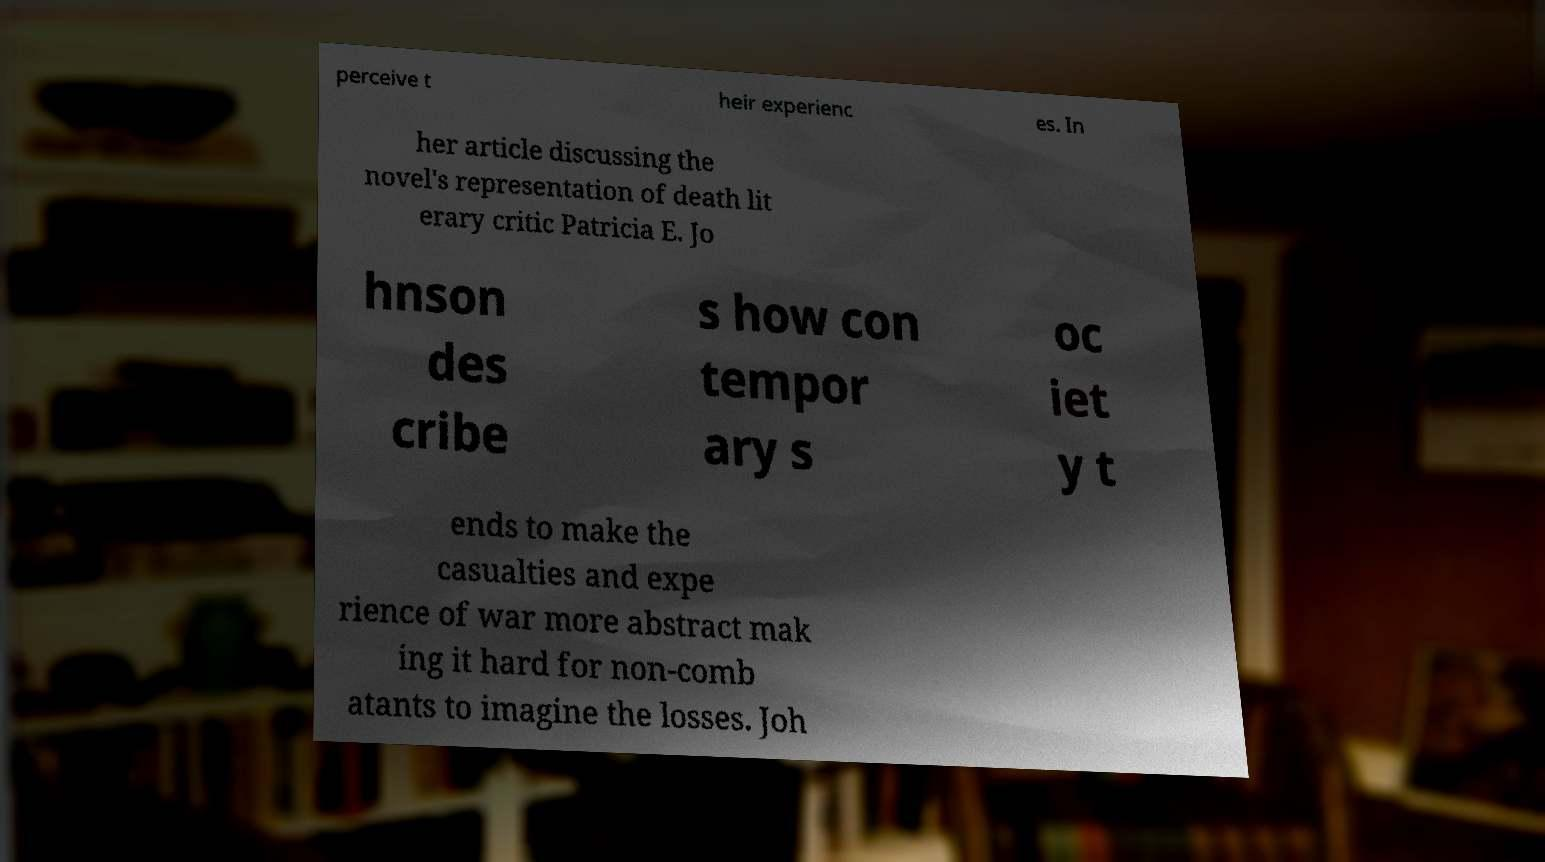I need the written content from this picture converted into text. Can you do that? perceive t heir experienc es. In her article discussing the novel's representation of death lit erary critic Patricia E. Jo hnson des cribe s how con tempor ary s oc iet y t ends to make the casualties and expe rience of war more abstract mak ing it hard for non-comb atants to imagine the losses. Joh 